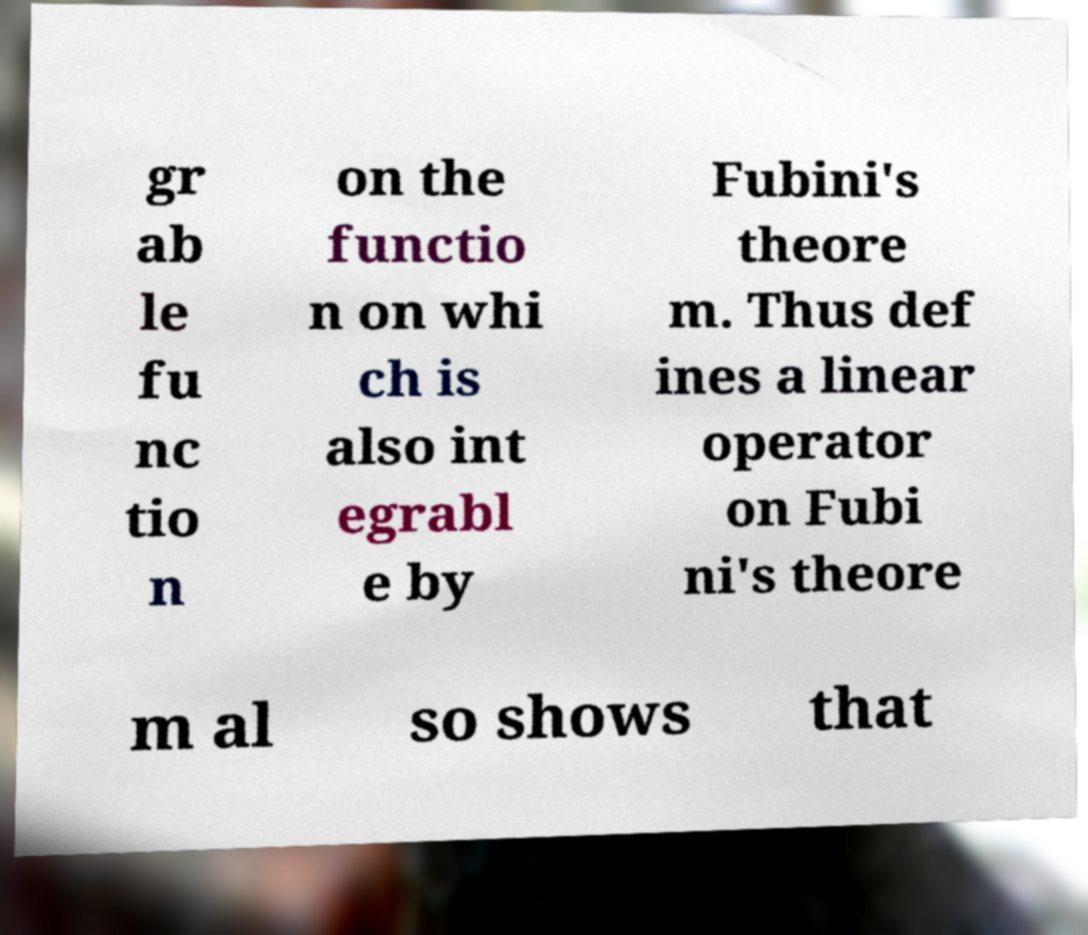Could you extract and type out the text from this image? gr ab le fu nc tio n on the functio n on whi ch is also int egrabl e by Fubini's theore m. Thus def ines a linear operator on Fubi ni's theore m al so shows that 